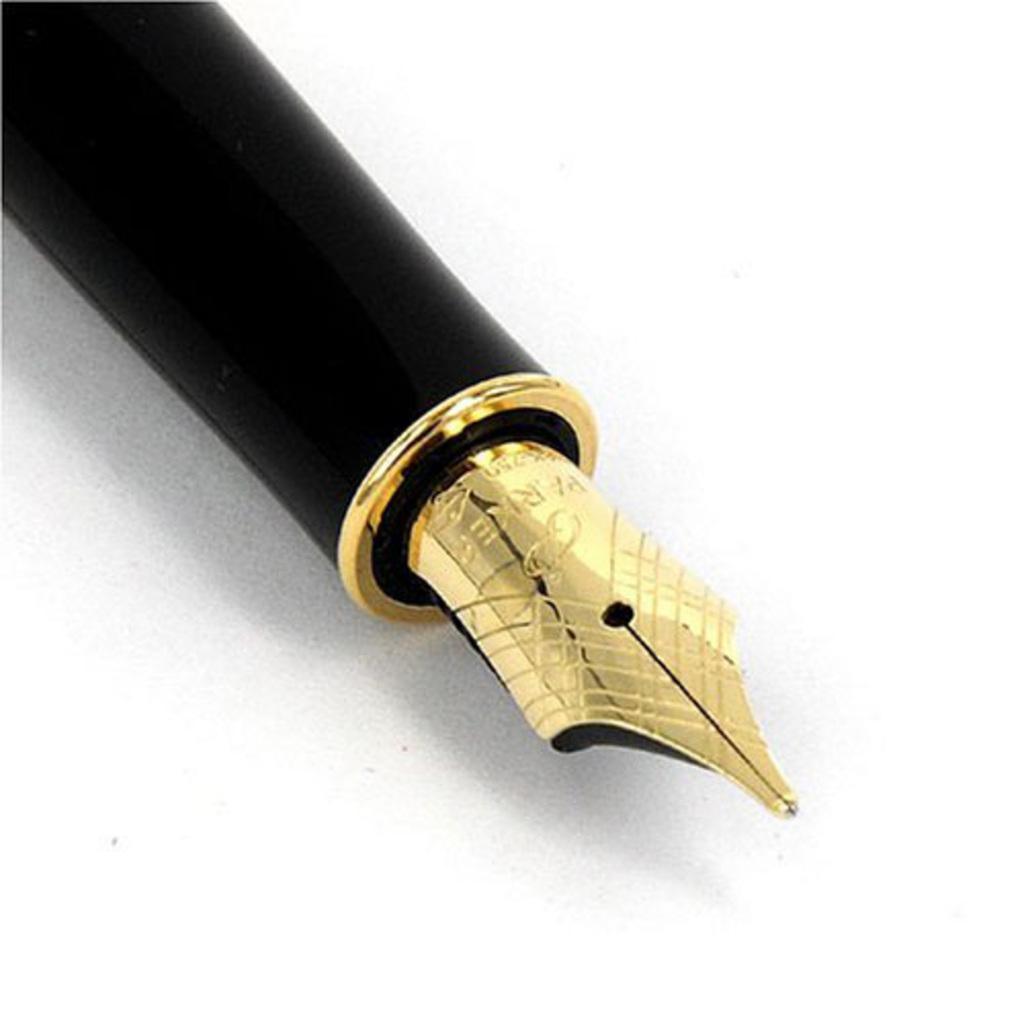Can you describe this image briefly? In this picture I can see ink pen. 